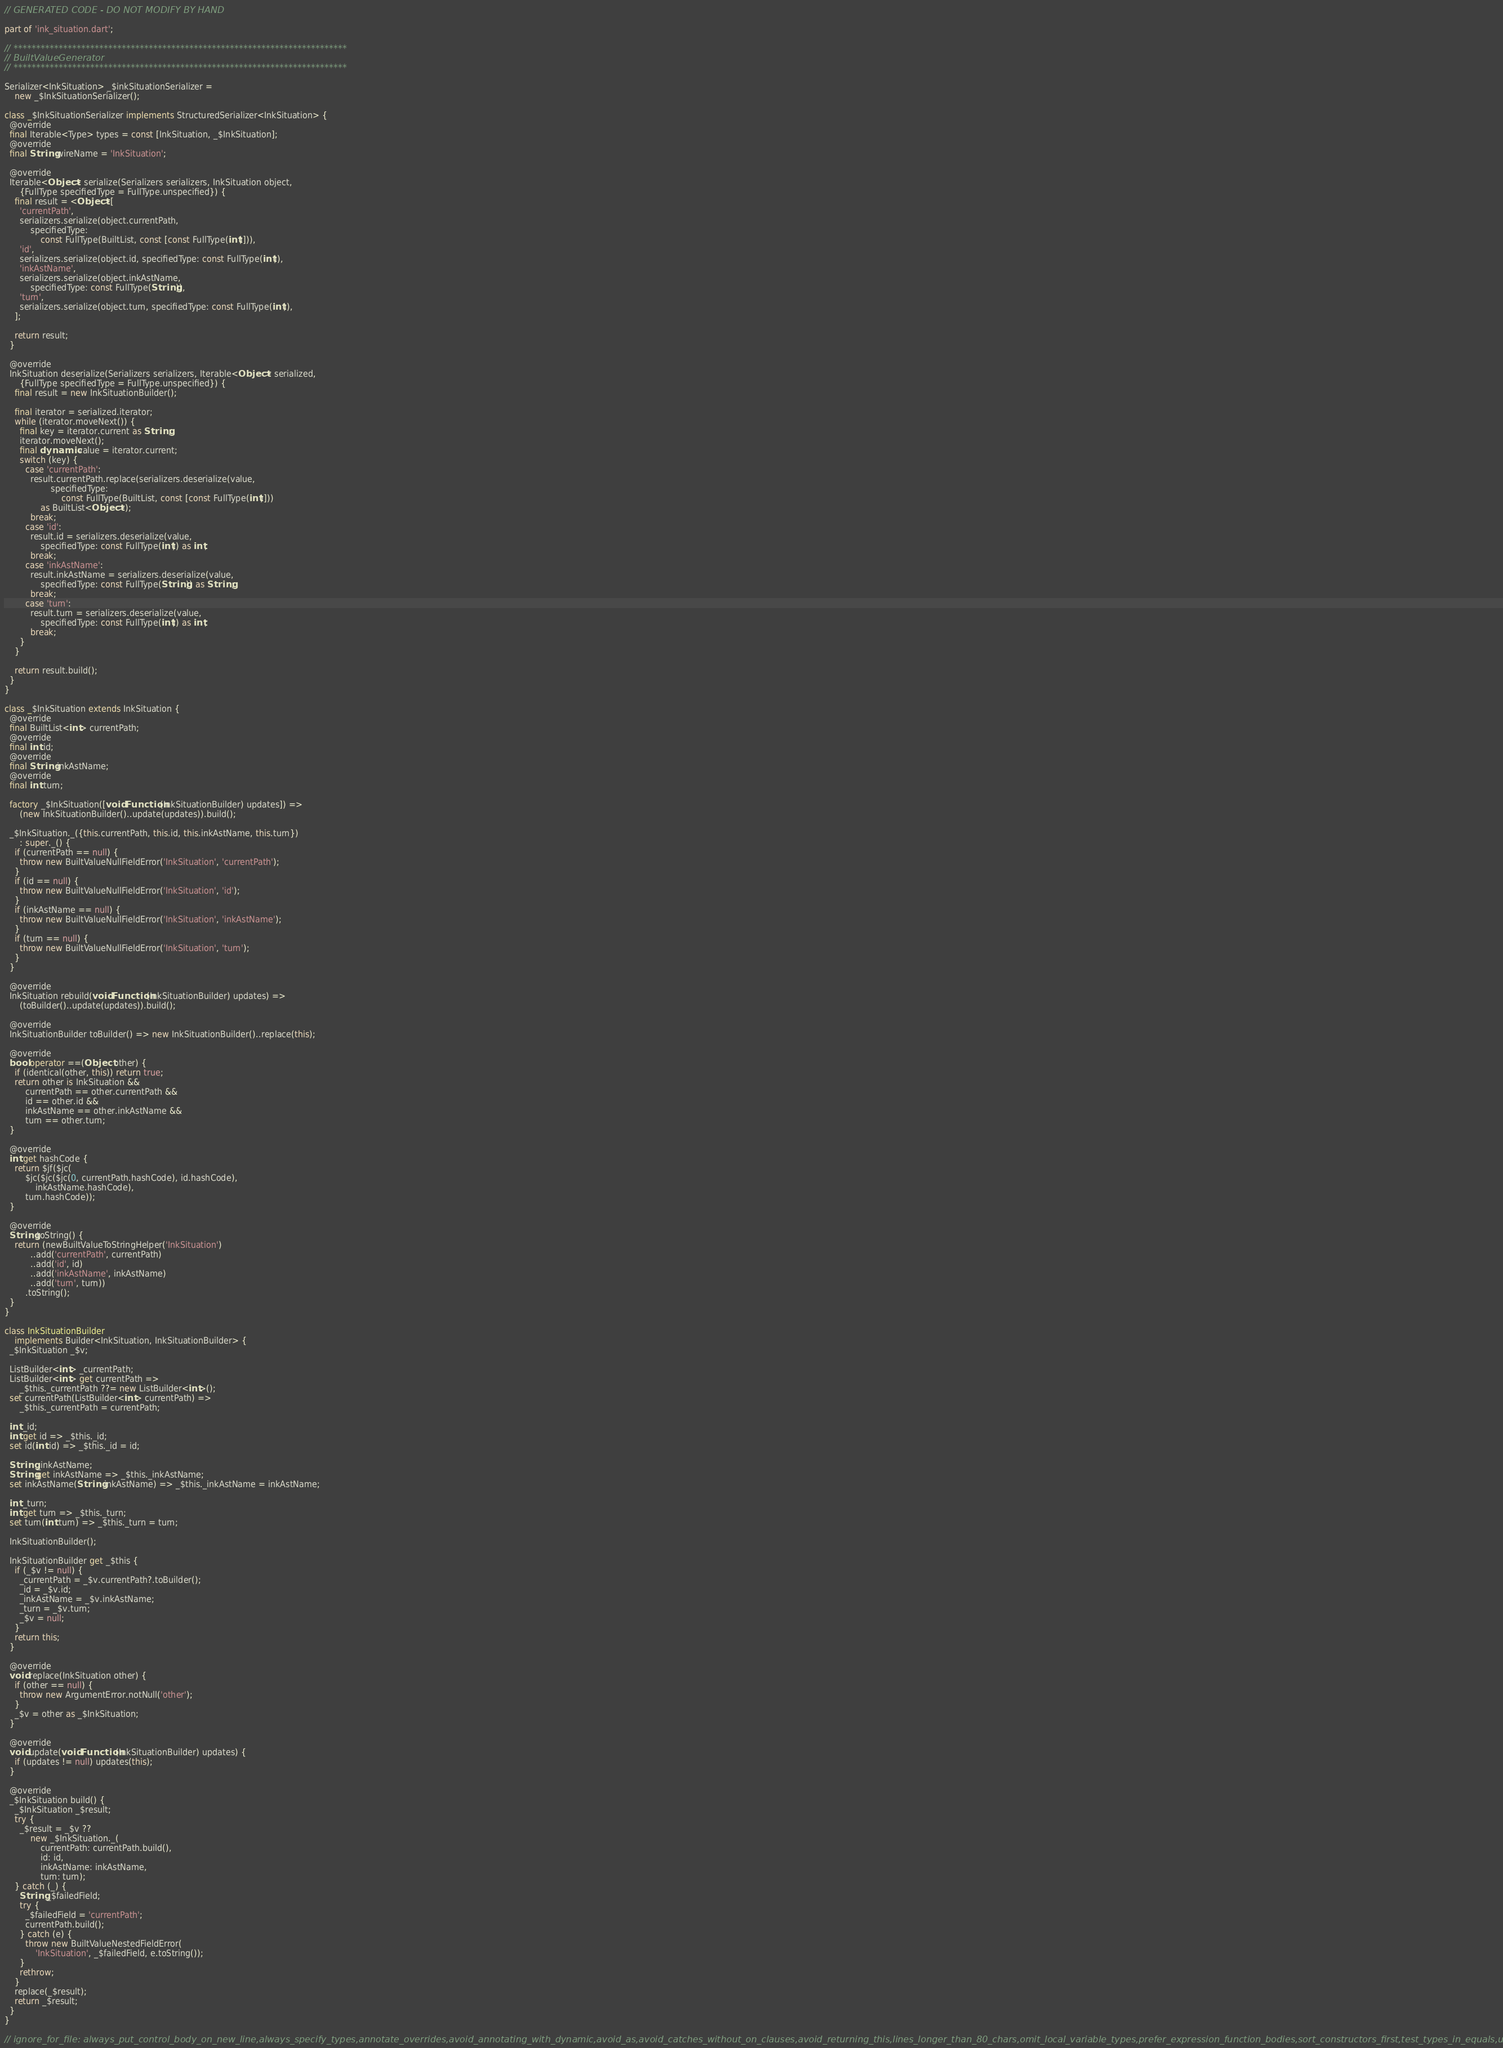<code> <loc_0><loc_0><loc_500><loc_500><_Dart_>// GENERATED CODE - DO NOT MODIFY BY HAND

part of 'ink_situation.dart';

// **************************************************************************
// BuiltValueGenerator
// **************************************************************************

Serializer<InkSituation> _$inkSituationSerializer =
    new _$InkSituationSerializer();

class _$InkSituationSerializer implements StructuredSerializer<InkSituation> {
  @override
  final Iterable<Type> types = const [InkSituation, _$InkSituation];
  @override
  final String wireName = 'InkSituation';

  @override
  Iterable<Object> serialize(Serializers serializers, InkSituation object,
      {FullType specifiedType = FullType.unspecified}) {
    final result = <Object>[
      'currentPath',
      serializers.serialize(object.currentPath,
          specifiedType:
              const FullType(BuiltList, const [const FullType(int)])),
      'id',
      serializers.serialize(object.id, specifiedType: const FullType(int)),
      'inkAstName',
      serializers.serialize(object.inkAstName,
          specifiedType: const FullType(String)),
      'turn',
      serializers.serialize(object.turn, specifiedType: const FullType(int)),
    ];

    return result;
  }

  @override
  InkSituation deserialize(Serializers serializers, Iterable<Object> serialized,
      {FullType specifiedType = FullType.unspecified}) {
    final result = new InkSituationBuilder();

    final iterator = serialized.iterator;
    while (iterator.moveNext()) {
      final key = iterator.current as String;
      iterator.moveNext();
      final dynamic value = iterator.current;
      switch (key) {
        case 'currentPath':
          result.currentPath.replace(serializers.deserialize(value,
                  specifiedType:
                      const FullType(BuiltList, const [const FullType(int)]))
              as BuiltList<Object>);
          break;
        case 'id':
          result.id = serializers.deserialize(value,
              specifiedType: const FullType(int)) as int;
          break;
        case 'inkAstName':
          result.inkAstName = serializers.deserialize(value,
              specifiedType: const FullType(String)) as String;
          break;
        case 'turn':
          result.turn = serializers.deserialize(value,
              specifiedType: const FullType(int)) as int;
          break;
      }
    }

    return result.build();
  }
}

class _$InkSituation extends InkSituation {
  @override
  final BuiltList<int> currentPath;
  @override
  final int id;
  @override
  final String inkAstName;
  @override
  final int turn;

  factory _$InkSituation([void Function(InkSituationBuilder) updates]) =>
      (new InkSituationBuilder()..update(updates)).build();

  _$InkSituation._({this.currentPath, this.id, this.inkAstName, this.turn})
      : super._() {
    if (currentPath == null) {
      throw new BuiltValueNullFieldError('InkSituation', 'currentPath');
    }
    if (id == null) {
      throw new BuiltValueNullFieldError('InkSituation', 'id');
    }
    if (inkAstName == null) {
      throw new BuiltValueNullFieldError('InkSituation', 'inkAstName');
    }
    if (turn == null) {
      throw new BuiltValueNullFieldError('InkSituation', 'turn');
    }
  }

  @override
  InkSituation rebuild(void Function(InkSituationBuilder) updates) =>
      (toBuilder()..update(updates)).build();

  @override
  InkSituationBuilder toBuilder() => new InkSituationBuilder()..replace(this);

  @override
  bool operator ==(Object other) {
    if (identical(other, this)) return true;
    return other is InkSituation &&
        currentPath == other.currentPath &&
        id == other.id &&
        inkAstName == other.inkAstName &&
        turn == other.turn;
  }

  @override
  int get hashCode {
    return $jf($jc(
        $jc($jc($jc(0, currentPath.hashCode), id.hashCode),
            inkAstName.hashCode),
        turn.hashCode));
  }

  @override
  String toString() {
    return (newBuiltValueToStringHelper('InkSituation')
          ..add('currentPath', currentPath)
          ..add('id', id)
          ..add('inkAstName', inkAstName)
          ..add('turn', turn))
        .toString();
  }
}

class InkSituationBuilder
    implements Builder<InkSituation, InkSituationBuilder> {
  _$InkSituation _$v;

  ListBuilder<int> _currentPath;
  ListBuilder<int> get currentPath =>
      _$this._currentPath ??= new ListBuilder<int>();
  set currentPath(ListBuilder<int> currentPath) =>
      _$this._currentPath = currentPath;

  int _id;
  int get id => _$this._id;
  set id(int id) => _$this._id = id;

  String _inkAstName;
  String get inkAstName => _$this._inkAstName;
  set inkAstName(String inkAstName) => _$this._inkAstName = inkAstName;

  int _turn;
  int get turn => _$this._turn;
  set turn(int turn) => _$this._turn = turn;

  InkSituationBuilder();

  InkSituationBuilder get _$this {
    if (_$v != null) {
      _currentPath = _$v.currentPath?.toBuilder();
      _id = _$v.id;
      _inkAstName = _$v.inkAstName;
      _turn = _$v.turn;
      _$v = null;
    }
    return this;
  }

  @override
  void replace(InkSituation other) {
    if (other == null) {
      throw new ArgumentError.notNull('other');
    }
    _$v = other as _$InkSituation;
  }

  @override
  void update(void Function(InkSituationBuilder) updates) {
    if (updates != null) updates(this);
  }

  @override
  _$InkSituation build() {
    _$InkSituation _$result;
    try {
      _$result = _$v ??
          new _$InkSituation._(
              currentPath: currentPath.build(),
              id: id,
              inkAstName: inkAstName,
              turn: turn);
    } catch (_) {
      String _$failedField;
      try {
        _$failedField = 'currentPath';
        currentPath.build();
      } catch (e) {
        throw new BuiltValueNestedFieldError(
            'InkSituation', _$failedField, e.toString());
      }
      rethrow;
    }
    replace(_$result);
    return _$result;
  }
}

// ignore_for_file: always_put_control_body_on_new_line,always_specify_types,annotate_overrides,avoid_annotating_with_dynamic,avoid_as,avoid_catches_without_on_clauses,avoid_returning_this,lines_longer_than_80_chars,omit_local_variable_types,prefer_expression_function_bodies,sort_constructors_first,test_types_in_equals,unnecessary_const,unnecessary_new
</code> 